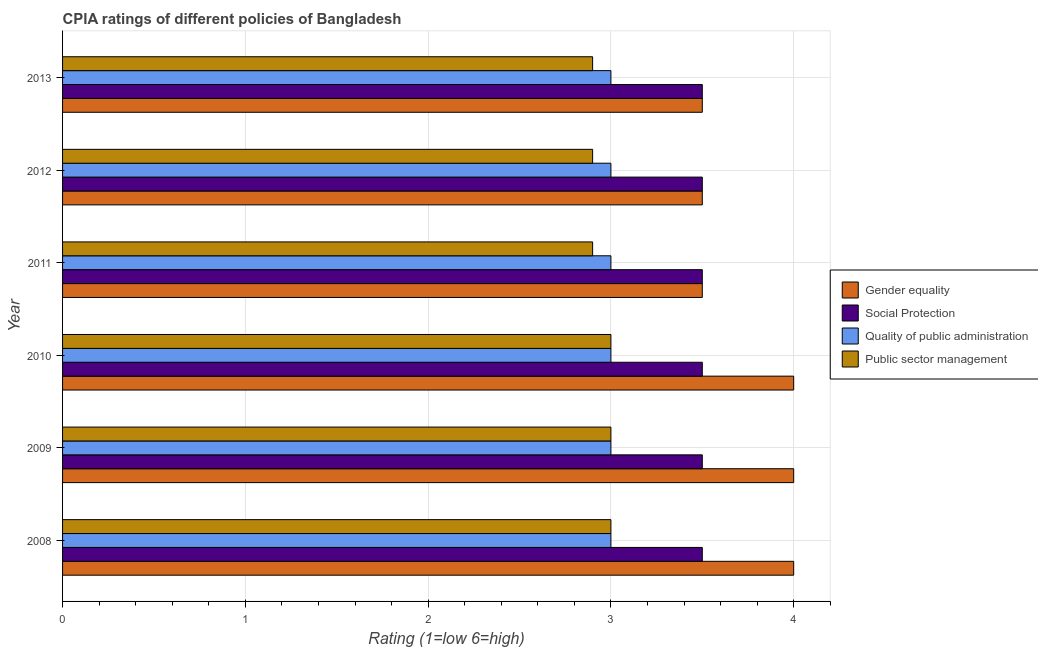Are the number of bars per tick equal to the number of legend labels?
Keep it short and to the point. Yes. Are the number of bars on each tick of the Y-axis equal?
Give a very brief answer. Yes. How many bars are there on the 3rd tick from the bottom?
Keep it short and to the point. 4. Across all years, what is the maximum cpia rating of quality of public administration?
Keep it short and to the point. 3. In which year was the cpia rating of public sector management minimum?
Offer a terse response. 2011. What is the difference between the cpia rating of gender equality in 2013 and the cpia rating of public sector management in 2008?
Your response must be concise. 0.5. What is the average cpia rating of gender equality per year?
Provide a succinct answer. 3.75. What is the ratio of the cpia rating of gender equality in 2008 to that in 2012?
Provide a succinct answer. 1.14. Is the cpia rating of quality of public administration in 2008 less than that in 2012?
Ensure brevity in your answer.  No. Is the difference between the cpia rating of quality of public administration in 2009 and 2010 greater than the difference between the cpia rating of social protection in 2009 and 2010?
Provide a short and direct response. No. In how many years, is the cpia rating of quality of public administration greater than the average cpia rating of quality of public administration taken over all years?
Give a very brief answer. 0. What does the 3rd bar from the top in 2009 represents?
Offer a terse response. Social Protection. What does the 2nd bar from the bottom in 2009 represents?
Your response must be concise. Social Protection. Is it the case that in every year, the sum of the cpia rating of gender equality and cpia rating of social protection is greater than the cpia rating of quality of public administration?
Provide a succinct answer. Yes. Are all the bars in the graph horizontal?
Keep it short and to the point. Yes. How many years are there in the graph?
Keep it short and to the point. 6. What is the difference between two consecutive major ticks on the X-axis?
Ensure brevity in your answer.  1. Where does the legend appear in the graph?
Provide a short and direct response. Center right. How many legend labels are there?
Your answer should be compact. 4. What is the title of the graph?
Provide a short and direct response. CPIA ratings of different policies of Bangladesh. What is the label or title of the Y-axis?
Provide a short and direct response. Year. What is the Rating (1=low 6=high) in Public sector management in 2008?
Your answer should be very brief. 3. What is the Rating (1=low 6=high) of Public sector management in 2009?
Provide a succinct answer. 3. What is the Rating (1=low 6=high) of Public sector management in 2010?
Provide a short and direct response. 3. What is the Rating (1=low 6=high) in Gender equality in 2012?
Ensure brevity in your answer.  3.5. What is the Rating (1=low 6=high) in Social Protection in 2012?
Provide a short and direct response. 3.5. What is the Rating (1=low 6=high) in Gender equality in 2013?
Your answer should be very brief. 3.5. What is the Rating (1=low 6=high) of Social Protection in 2013?
Keep it short and to the point. 3.5. Across all years, what is the maximum Rating (1=low 6=high) of Social Protection?
Your response must be concise. 3.5. Across all years, what is the maximum Rating (1=low 6=high) in Quality of public administration?
Provide a succinct answer. 3. Across all years, what is the minimum Rating (1=low 6=high) of Gender equality?
Provide a short and direct response. 3.5. Across all years, what is the minimum Rating (1=low 6=high) in Social Protection?
Your response must be concise. 3.5. What is the total Rating (1=low 6=high) of Social Protection in the graph?
Your answer should be very brief. 21. What is the total Rating (1=low 6=high) of Public sector management in the graph?
Ensure brevity in your answer.  17.7. What is the difference between the Rating (1=low 6=high) in Social Protection in 2008 and that in 2009?
Provide a succinct answer. 0. What is the difference between the Rating (1=low 6=high) of Public sector management in 2008 and that in 2009?
Make the answer very short. 0. What is the difference between the Rating (1=low 6=high) of Social Protection in 2008 and that in 2010?
Offer a terse response. 0. What is the difference between the Rating (1=low 6=high) of Public sector management in 2008 and that in 2010?
Provide a short and direct response. 0. What is the difference between the Rating (1=low 6=high) of Public sector management in 2008 and that in 2011?
Make the answer very short. 0.1. What is the difference between the Rating (1=low 6=high) in Quality of public administration in 2008 and that in 2012?
Make the answer very short. 0. What is the difference between the Rating (1=low 6=high) of Public sector management in 2008 and that in 2012?
Make the answer very short. 0.1. What is the difference between the Rating (1=low 6=high) in Gender equality in 2008 and that in 2013?
Offer a terse response. 0.5. What is the difference between the Rating (1=low 6=high) in Social Protection in 2008 and that in 2013?
Give a very brief answer. 0. What is the difference between the Rating (1=low 6=high) in Quality of public administration in 2008 and that in 2013?
Make the answer very short. 0. What is the difference between the Rating (1=low 6=high) in Public sector management in 2008 and that in 2013?
Ensure brevity in your answer.  0.1. What is the difference between the Rating (1=low 6=high) of Gender equality in 2009 and that in 2010?
Offer a very short reply. 0. What is the difference between the Rating (1=low 6=high) of Quality of public administration in 2009 and that in 2010?
Give a very brief answer. 0. What is the difference between the Rating (1=low 6=high) in Public sector management in 2009 and that in 2011?
Ensure brevity in your answer.  0.1. What is the difference between the Rating (1=low 6=high) in Social Protection in 2009 and that in 2012?
Make the answer very short. 0. What is the difference between the Rating (1=low 6=high) of Public sector management in 2009 and that in 2012?
Ensure brevity in your answer.  0.1. What is the difference between the Rating (1=low 6=high) of Gender equality in 2009 and that in 2013?
Your response must be concise. 0.5. What is the difference between the Rating (1=low 6=high) of Public sector management in 2009 and that in 2013?
Offer a terse response. 0.1. What is the difference between the Rating (1=low 6=high) in Social Protection in 2010 and that in 2011?
Your answer should be very brief. 0. What is the difference between the Rating (1=low 6=high) in Gender equality in 2010 and that in 2012?
Give a very brief answer. 0.5. What is the difference between the Rating (1=low 6=high) of Social Protection in 2010 and that in 2012?
Your answer should be very brief. 0. What is the difference between the Rating (1=low 6=high) in Quality of public administration in 2010 and that in 2012?
Your answer should be compact. 0. What is the difference between the Rating (1=low 6=high) of Public sector management in 2010 and that in 2012?
Give a very brief answer. 0.1. What is the difference between the Rating (1=low 6=high) of Social Protection in 2010 and that in 2013?
Offer a very short reply. 0. What is the difference between the Rating (1=low 6=high) of Gender equality in 2011 and that in 2012?
Provide a short and direct response. 0. What is the difference between the Rating (1=low 6=high) in Social Protection in 2011 and that in 2012?
Offer a very short reply. 0. What is the difference between the Rating (1=low 6=high) in Public sector management in 2011 and that in 2012?
Your answer should be very brief. 0. What is the difference between the Rating (1=low 6=high) in Social Protection in 2011 and that in 2013?
Keep it short and to the point. 0. What is the difference between the Rating (1=low 6=high) of Quality of public administration in 2011 and that in 2013?
Give a very brief answer. 0. What is the difference between the Rating (1=low 6=high) of Quality of public administration in 2012 and that in 2013?
Ensure brevity in your answer.  0. What is the difference between the Rating (1=low 6=high) of Gender equality in 2008 and the Rating (1=low 6=high) of Quality of public administration in 2009?
Your answer should be very brief. 1. What is the difference between the Rating (1=low 6=high) in Social Protection in 2008 and the Rating (1=low 6=high) in Public sector management in 2009?
Provide a short and direct response. 0.5. What is the difference between the Rating (1=low 6=high) in Quality of public administration in 2008 and the Rating (1=low 6=high) in Public sector management in 2009?
Your answer should be compact. 0. What is the difference between the Rating (1=low 6=high) in Gender equality in 2008 and the Rating (1=low 6=high) in Public sector management in 2010?
Ensure brevity in your answer.  1. What is the difference between the Rating (1=low 6=high) of Social Protection in 2008 and the Rating (1=low 6=high) of Quality of public administration in 2010?
Ensure brevity in your answer.  0.5. What is the difference between the Rating (1=low 6=high) of Quality of public administration in 2008 and the Rating (1=low 6=high) of Public sector management in 2010?
Your answer should be compact. 0. What is the difference between the Rating (1=low 6=high) of Gender equality in 2008 and the Rating (1=low 6=high) of Quality of public administration in 2011?
Your answer should be very brief. 1. What is the difference between the Rating (1=low 6=high) of Gender equality in 2008 and the Rating (1=low 6=high) of Public sector management in 2011?
Ensure brevity in your answer.  1.1. What is the difference between the Rating (1=low 6=high) in Quality of public administration in 2008 and the Rating (1=low 6=high) in Public sector management in 2011?
Make the answer very short. 0.1. What is the difference between the Rating (1=low 6=high) in Social Protection in 2008 and the Rating (1=low 6=high) in Public sector management in 2012?
Give a very brief answer. 0.6. What is the difference between the Rating (1=low 6=high) of Quality of public administration in 2008 and the Rating (1=low 6=high) of Public sector management in 2012?
Provide a succinct answer. 0.1. What is the difference between the Rating (1=low 6=high) in Social Protection in 2008 and the Rating (1=low 6=high) in Quality of public administration in 2013?
Make the answer very short. 0.5. What is the difference between the Rating (1=low 6=high) of Gender equality in 2009 and the Rating (1=low 6=high) of Social Protection in 2010?
Your response must be concise. 0.5. What is the difference between the Rating (1=low 6=high) in Social Protection in 2009 and the Rating (1=low 6=high) in Quality of public administration in 2010?
Make the answer very short. 0.5. What is the difference between the Rating (1=low 6=high) of Gender equality in 2009 and the Rating (1=low 6=high) of Social Protection in 2011?
Make the answer very short. 0.5. What is the difference between the Rating (1=low 6=high) in Gender equality in 2009 and the Rating (1=low 6=high) in Public sector management in 2011?
Offer a terse response. 1.1. What is the difference between the Rating (1=low 6=high) in Social Protection in 2009 and the Rating (1=low 6=high) in Quality of public administration in 2011?
Give a very brief answer. 0.5. What is the difference between the Rating (1=low 6=high) of Social Protection in 2009 and the Rating (1=low 6=high) of Public sector management in 2011?
Ensure brevity in your answer.  0.6. What is the difference between the Rating (1=low 6=high) in Gender equality in 2009 and the Rating (1=low 6=high) in Quality of public administration in 2012?
Offer a terse response. 1. What is the difference between the Rating (1=low 6=high) in Gender equality in 2009 and the Rating (1=low 6=high) in Public sector management in 2012?
Make the answer very short. 1.1. What is the difference between the Rating (1=low 6=high) of Social Protection in 2009 and the Rating (1=low 6=high) of Quality of public administration in 2012?
Make the answer very short. 0.5. What is the difference between the Rating (1=low 6=high) of Social Protection in 2009 and the Rating (1=low 6=high) of Public sector management in 2012?
Provide a succinct answer. 0.6. What is the difference between the Rating (1=low 6=high) in Gender equality in 2009 and the Rating (1=low 6=high) in Social Protection in 2013?
Provide a short and direct response. 0.5. What is the difference between the Rating (1=low 6=high) in Gender equality in 2009 and the Rating (1=low 6=high) in Quality of public administration in 2013?
Your answer should be compact. 1. What is the difference between the Rating (1=low 6=high) in Gender equality in 2009 and the Rating (1=low 6=high) in Public sector management in 2013?
Ensure brevity in your answer.  1.1. What is the difference between the Rating (1=low 6=high) in Quality of public administration in 2009 and the Rating (1=low 6=high) in Public sector management in 2013?
Your response must be concise. 0.1. What is the difference between the Rating (1=low 6=high) in Gender equality in 2010 and the Rating (1=low 6=high) in Public sector management in 2011?
Offer a very short reply. 1.1. What is the difference between the Rating (1=low 6=high) in Social Protection in 2010 and the Rating (1=low 6=high) in Public sector management in 2011?
Your answer should be compact. 0.6. What is the difference between the Rating (1=low 6=high) of Gender equality in 2010 and the Rating (1=low 6=high) of Social Protection in 2012?
Your answer should be compact. 0.5. What is the difference between the Rating (1=low 6=high) in Gender equality in 2010 and the Rating (1=low 6=high) in Quality of public administration in 2012?
Provide a succinct answer. 1. What is the difference between the Rating (1=low 6=high) of Social Protection in 2010 and the Rating (1=low 6=high) of Public sector management in 2012?
Give a very brief answer. 0.6. What is the difference between the Rating (1=low 6=high) in Gender equality in 2010 and the Rating (1=low 6=high) in Social Protection in 2013?
Offer a terse response. 0.5. What is the difference between the Rating (1=low 6=high) in Gender equality in 2010 and the Rating (1=low 6=high) in Quality of public administration in 2013?
Offer a very short reply. 1. What is the difference between the Rating (1=low 6=high) in Gender equality in 2010 and the Rating (1=low 6=high) in Public sector management in 2013?
Your answer should be compact. 1.1. What is the difference between the Rating (1=low 6=high) of Quality of public administration in 2010 and the Rating (1=low 6=high) of Public sector management in 2013?
Make the answer very short. 0.1. What is the difference between the Rating (1=low 6=high) of Gender equality in 2011 and the Rating (1=low 6=high) of Quality of public administration in 2012?
Keep it short and to the point. 0.5. What is the difference between the Rating (1=low 6=high) in Social Protection in 2011 and the Rating (1=low 6=high) in Quality of public administration in 2012?
Provide a short and direct response. 0.5. What is the difference between the Rating (1=low 6=high) of Social Protection in 2011 and the Rating (1=low 6=high) of Public sector management in 2012?
Give a very brief answer. 0.6. What is the difference between the Rating (1=low 6=high) in Quality of public administration in 2011 and the Rating (1=low 6=high) in Public sector management in 2012?
Offer a very short reply. 0.1. What is the difference between the Rating (1=low 6=high) in Gender equality in 2011 and the Rating (1=low 6=high) in Social Protection in 2013?
Offer a very short reply. 0. What is the difference between the Rating (1=low 6=high) of Gender equality in 2011 and the Rating (1=low 6=high) of Quality of public administration in 2013?
Make the answer very short. 0.5. What is the difference between the Rating (1=low 6=high) of Gender equality in 2011 and the Rating (1=low 6=high) of Public sector management in 2013?
Provide a succinct answer. 0.6. What is the difference between the Rating (1=low 6=high) in Quality of public administration in 2011 and the Rating (1=low 6=high) in Public sector management in 2013?
Your response must be concise. 0.1. What is the difference between the Rating (1=low 6=high) of Gender equality in 2012 and the Rating (1=low 6=high) of Social Protection in 2013?
Provide a short and direct response. 0. What is the difference between the Rating (1=low 6=high) in Gender equality in 2012 and the Rating (1=low 6=high) in Public sector management in 2013?
Offer a very short reply. 0.6. What is the difference between the Rating (1=low 6=high) of Social Protection in 2012 and the Rating (1=low 6=high) of Quality of public administration in 2013?
Offer a very short reply. 0.5. What is the average Rating (1=low 6=high) of Gender equality per year?
Give a very brief answer. 3.75. What is the average Rating (1=low 6=high) in Social Protection per year?
Your answer should be compact. 3.5. What is the average Rating (1=low 6=high) in Quality of public administration per year?
Offer a very short reply. 3. What is the average Rating (1=low 6=high) in Public sector management per year?
Keep it short and to the point. 2.95. In the year 2008, what is the difference between the Rating (1=low 6=high) in Gender equality and Rating (1=low 6=high) in Social Protection?
Keep it short and to the point. 0.5. In the year 2008, what is the difference between the Rating (1=low 6=high) of Gender equality and Rating (1=low 6=high) of Quality of public administration?
Offer a terse response. 1. In the year 2008, what is the difference between the Rating (1=low 6=high) in Social Protection and Rating (1=low 6=high) in Quality of public administration?
Keep it short and to the point. 0.5. In the year 2008, what is the difference between the Rating (1=low 6=high) in Social Protection and Rating (1=low 6=high) in Public sector management?
Give a very brief answer. 0.5. In the year 2008, what is the difference between the Rating (1=low 6=high) in Quality of public administration and Rating (1=low 6=high) in Public sector management?
Your response must be concise. 0. In the year 2009, what is the difference between the Rating (1=low 6=high) in Gender equality and Rating (1=low 6=high) in Social Protection?
Make the answer very short. 0.5. In the year 2009, what is the difference between the Rating (1=low 6=high) of Gender equality and Rating (1=low 6=high) of Quality of public administration?
Your answer should be compact. 1. In the year 2009, what is the difference between the Rating (1=low 6=high) in Gender equality and Rating (1=low 6=high) in Public sector management?
Your answer should be very brief. 1. In the year 2009, what is the difference between the Rating (1=low 6=high) of Social Protection and Rating (1=low 6=high) of Public sector management?
Keep it short and to the point. 0.5. In the year 2009, what is the difference between the Rating (1=low 6=high) in Quality of public administration and Rating (1=low 6=high) in Public sector management?
Give a very brief answer. 0. In the year 2010, what is the difference between the Rating (1=low 6=high) in Gender equality and Rating (1=low 6=high) in Public sector management?
Offer a very short reply. 1. In the year 2011, what is the difference between the Rating (1=low 6=high) of Gender equality and Rating (1=low 6=high) of Quality of public administration?
Offer a terse response. 0.5. In the year 2011, what is the difference between the Rating (1=low 6=high) in Gender equality and Rating (1=low 6=high) in Public sector management?
Offer a very short reply. 0.6. In the year 2011, what is the difference between the Rating (1=low 6=high) of Social Protection and Rating (1=low 6=high) of Quality of public administration?
Make the answer very short. 0.5. In the year 2011, what is the difference between the Rating (1=low 6=high) in Social Protection and Rating (1=low 6=high) in Public sector management?
Make the answer very short. 0.6. In the year 2012, what is the difference between the Rating (1=low 6=high) in Gender equality and Rating (1=low 6=high) in Social Protection?
Your response must be concise. 0. In the year 2012, what is the difference between the Rating (1=low 6=high) in Gender equality and Rating (1=low 6=high) in Quality of public administration?
Offer a terse response. 0.5. In the year 2012, what is the difference between the Rating (1=low 6=high) in Gender equality and Rating (1=low 6=high) in Public sector management?
Your response must be concise. 0.6. In the year 2012, what is the difference between the Rating (1=low 6=high) in Social Protection and Rating (1=low 6=high) in Quality of public administration?
Offer a terse response. 0.5. In the year 2013, what is the difference between the Rating (1=low 6=high) of Gender equality and Rating (1=low 6=high) of Social Protection?
Ensure brevity in your answer.  0. In the year 2013, what is the difference between the Rating (1=low 6=high) in Gender equality and Rating (1=low 6=high) in Public sector management?
Provide a succinct answer. 0.6. In the year 2013, what is the difference between the Rating (1=low 6=high) of Quality of public administration and Rating (1=low 6=high) of Public sector management?
Ensure brevity in your answer.  0.1. What is the ratio of the Rating (1=low 6=high) of Gender equality in 2008 to that in 2009?
Provide a short and direct response. 1. What is the ratio of the Rating (1=low 6=high) of Quality of public administration in 2008 to that in 2009?
Your response must be concise. 1. What is the ratio of the Rating (1=low 6=high) of Public sector management in 2008 to that in 2009?
Offer a terse response. 1. What is the ratio of the Rating (1=low 6=high) of Social Protection in 2008 to that in 2010?
Ensure brevity in your answer.  1. What is the ratio of the Rating (1=low 6=high) in Public sector management in 2008 to that in 2010?
Offer a very short reply. 1. What is the ratio of the Rating (1=low 6=high) of Gender equality in 2008 to that in 2011?
Provide a succinct answer. 1.14. What is the ratio of the Rating (1=low 6=high) of Quality of public administration in 2008 to that in 2011?
Offer a terse response. 1. What is the ratio of the Rating (1=low 6=high) in Public sector management in 2008 to that in 2011?
Your answer should be compact. 1.03. What is the ratio of the Rating (1=low 6=high) in Gender equality in 2008 to that in 2012?
Your answer should be compact. 1.14. What is the ratio of the Rating (1=low 6=high) in Public sector management in 2008 to that in 2012?
Make the answer very short. 1.03. What is the ratio of the Rating (1=low 6=high) of Gender equality in 2008 to that in 2013?
Offer a terse response. 1.14. What is the ratio of the Rating (1=low 6=high) in Public sector management in 2008 to that in 2013?
Provide a succinct answer. 1.03. What is the ratio of the Rating (1=low 6=high) in Social Protection in 2009 to that in 2010?
Give a very brief answer. 1. What is the ratio of the Rating (1=low 6=high) of Quality of public administration in 2009 to that in 2010?
Your response must be concise. 1. What is the ratio of the Rating (1=low 6=high) in Public sector management in 2009 to that in 2010?
Make the answer very short. 1. What is the ratio of the Rating (1=low 6=high) in Gender equality in 2009 to that in 2011?
Keep it short and to the point. 1.14. What is the ratio of the Rating (1=low 6=high) in Social Protection in 2009 to that in 2011?
Keep it short and to the point. 1. What is the ratio of the Rating (1=low 6=high) of Public sector management in 2009 to that in 2011?
Give a very brief answer. 1.03. What is the ratio of the Rating (1=low 6=high) of Social Protection in 2009 to that in 2012?
Provide a short and direct response. 1. What is the ratio of the Rating (1=low 6=high) in Public sector management in 2009 to that in 2012?
Your response must be concise. 1.03. What is the ratio of the Rating (1=low 6=high) of Gender equality in 2009 to that in 2013?
Your answer should be compact. 1.14. What is the ratio of the Rating (1=low 6=high) of Public sector management in 2009 to that in 2013?
Your response must be concise. 1.03. What is the ratio of the Rating (1=low 6=high) of Gender equality in 2010 to that in 2011?
Your answer should be very brief. 1.14. What is the ratio of the Rating (1=low 6=high) of Public sector management in 2010 to that in 2011?
Offer a very short reply. 1.03. What is the ratio of the Rating (1=low 6=high) of Social Protection in 2010 to that in 2012?
Make the answer very short. 1. What is the ratio of the Rating (1=low 6=high) in Quality of public administration in 2010 to that in 2012?
Your response must be concise. 1. What is the ratio of the Rating (1=low 6=high) in Public sector management in 2010 to that in 2012?
Keep it short and to the point. 1.03. What is the ratio of the Rating (1=low 6=high) of Social Protection in 2010 to that in 2013?
Make the answer very short. 1. What is the ratio of the Rating (1=low 6=high) in Quality of public administration in 2010 to that in 2013?
Provide a short and direct response. 1. What is the ratio of the Rating (1=low 6=high) of Public sector management in 2010 to that in 2013?
Offer a very short reply. 1.03. What is the ratio of the Rating (1=low 6=high) of Gender equality in 2011 to that in 2012?
Offer a terse response. 1. What is the ratio of the Rating (1=low 6=high) in Social Protection in 2011 to that in 2012?
Offer a very short reply. 1. What is the ratio of the Rating (1=low 6=high) of Quality of public administration in 2011 to that in 2012?
Make the answer very short. 1. What is the ratio of the Rating (1=low 6=high) of Gender equality in 2011 to that in 2013?
Give a very brief answer. 1. What is the ratio of the Rating (1=low 6=high) of Social Protection in 2011 to that in 2013?
Make the answer very short. 1. What is the ratio of the Rating (1=low 6=high) of Quality of public administration in 2011 to that in 2013?
Offer a terse response. 1. What is the ratio of the Rating (1=low 6=high) in Public sector management in 2011 to that in 2013?
Offer a terse response. 1. What is the ratio of the Rating (1=low 6=high) in Social Protection in 2012 to that in 2013?
Provide a succinct answer. 1. What is the ratio of the Rating (1=low 6=high) of Quality of public administration in 2012 to that in 2013?
Offer a terse response. 1. What is the ratio of the Rating (1=low 6=high) in Public sector management in 2012 to that in 2013?
Offer a very short reply. 1. What is the difference between the highest and the second highest Rating (1=low 6=high) in Gender equality?
Your answer should be very brief. 0. What is the difference between the highest and the second highest Rating (1=low 6=high) in Quality of public administration?
Offer a very short reply. 0. What is the difference between the highest and the lowest Rating (1=low 6=high) of Quality of public administration?
Give a very brief answer. 0. What is the difference between the highest and the lowest Rating (1=low 6=high) of Public sector management?
Your response must be concise. 0.1. 